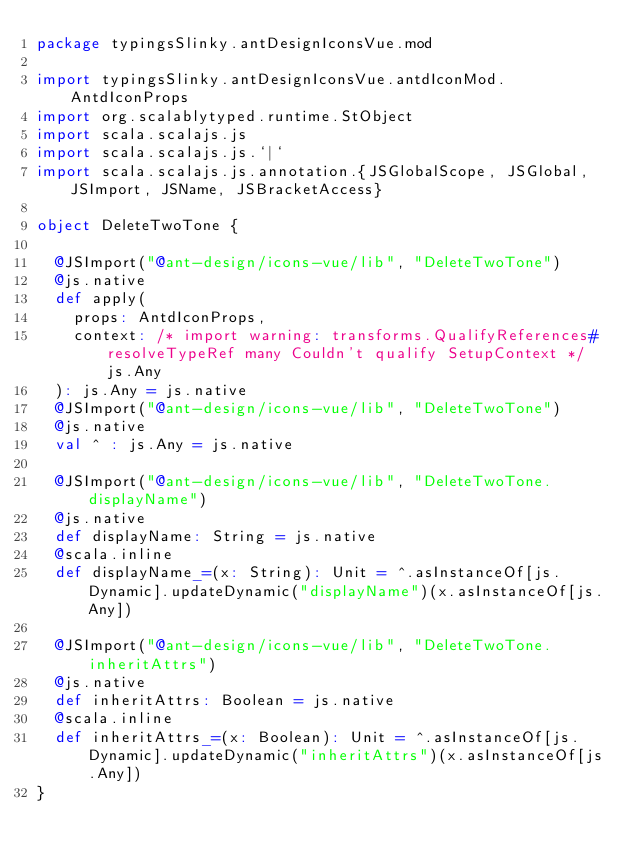<code> <loc_0><loc_0><loc_500><loc_500><_Scala_>package typingsSlinky.antDesignIconsVue.mod

import typingsSlinky.antDesignIconsVue.antdIconMod.AntdIconProps
import org.scalablytyped.runtime.StObject
import scala.scalajs.js
import scala.scalajs.js.`|`
import scala.scalajs.js.annotation.{JSGlobalScope, JSGlobal, JSImport, JSName, JSBracketAccess}

object DeleteTwoTone {
  
  @JSImport("@ant-design/icons-vue/lib", "DeleteTwoTone")
  @js.native
  def apply(
    props: AntdIconProps,
    context: /* import warning: transforms.QualifyReferences#resolveTypeRef many Couldn't qualify SetupContext */ js.Any
  ): js.Any = js.native
  @JSImport("@ant-design/icons-vue/lib", "DeleteTwoTone")
  @js.native
  val ^ : js.Any = js.native
  
  @JSImport("@ant-design/icons-vue/lib", "DeleteTwoTone.displayName")
  @js.native
  def displayName: String = js.native
  @scala.inline
  def displayName_=(x: String): Unit = ^.asInstanceOf[js.Dynamic].updateDynamic("displayName")(x.asInstanceOf[js.Any])
  
  @JSImport("@ant-design/icons-vue/lib", "DeleteTwoTone.inheritAttrs")
  @js.native
  def inheritAttrs: Boolean = js.native
  @scala.inline
  def inheritAttrs_=(x: Boolean): Unit = ^.asInstanceOf[js.Dynamic].updateDynamic("inheritAttrs")(x.asInstanceOf[js.Any])
}
</code> 